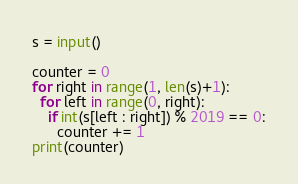<code> <loc_0><loc_0><loc_500><loc_500><_Python_>s = input()

counter = 0
for right in range(1, len(s)+1):
  for left in range(0, right):
    if int(s[left : right]) % 2019 == 0:
      counter += 1
print(counter)</code> 